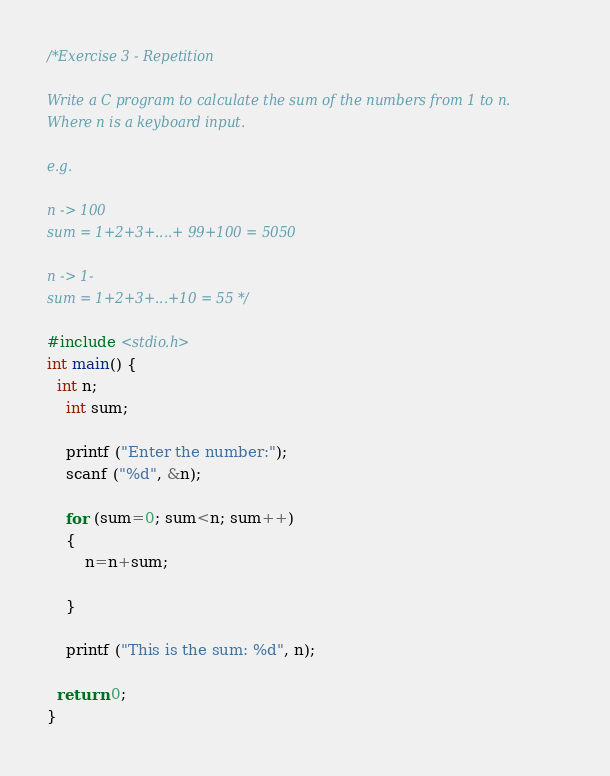<code> <loc_0><loc_0><loc_500><loc_500><_C_>/*Exercise 3 - Repetition

Write a C program to calculate the sum of the numbers from 1 to n.
Where n is a keyboard input.

e.g.

n -> 100
sum = 1+2+3+....+ 99+100 = 5050

n -> 1-
sum = 1+2+3+...+10 = 55 */

#include <stdio.h>
int main() {
  int n;
	int sum;
	
	printf ("Enter the number:");
	scanf ("%d", &n);
	
	for (sum=0; sum<n; sum++)
	{
		n=n+sum;
		
	}
	
	printf ("This is the sum: %d", n);

  return 0;
}

</code> 